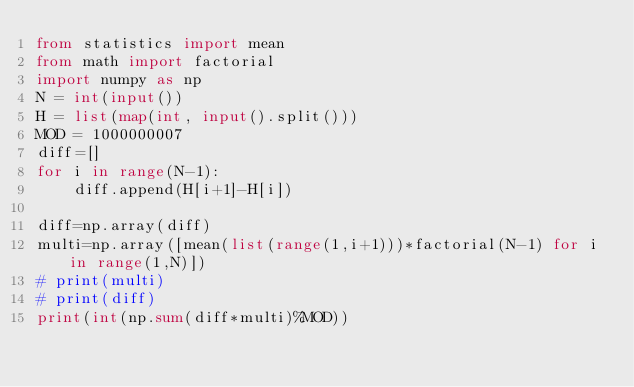Convert code to text. <code><loc_0><loc_0><loc_500><loc_500><_Python_>from statistics import mean
from math import factorial
import numpy as np
N = int(input())
H = list(map(int, input().split()))
MOD = 1000000007
diff=[]
for i in range(N-1):
    diff.append(H[i+1]-H[i])

diff=np.array(diff)
multi=np.array([mean(list(range(1,i+1)))*factorial(N-1) for i in range(1,N)])
# print(multi)
# print(diff)
print(int(np.sum(diff*multi)%MOD))</code> 